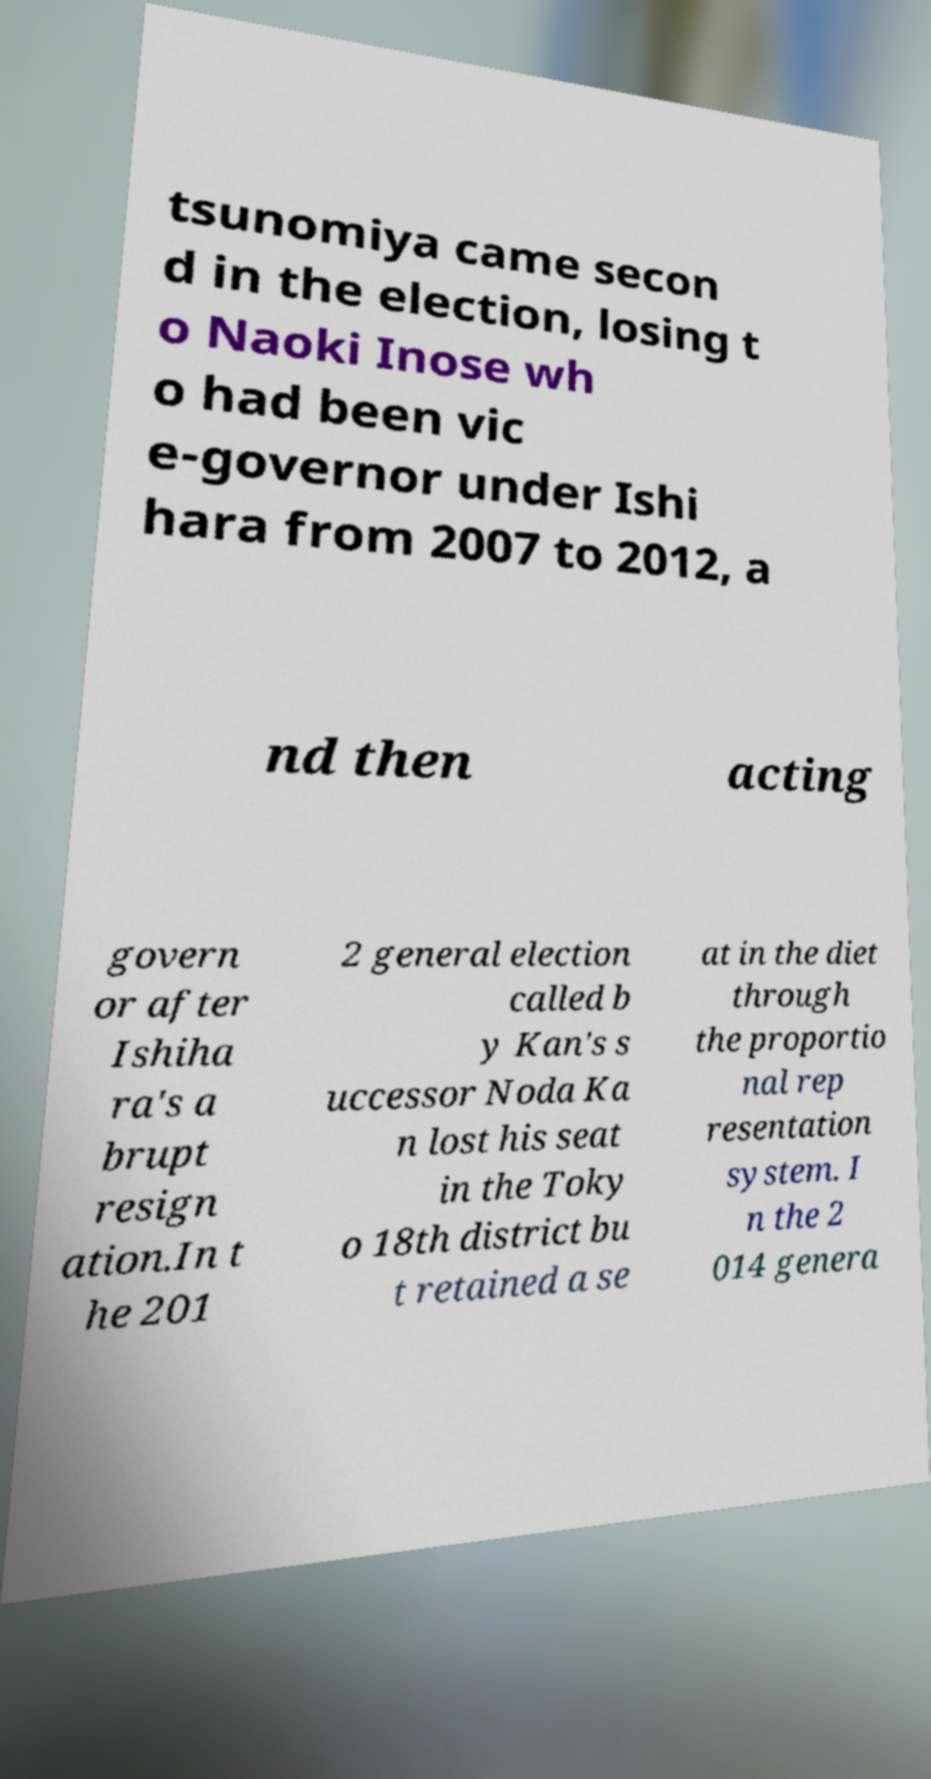Can you read and provide the text displayed in the image?This photo seems to have some interesting text. Can you extract and type it out for me? tsunomiya came secon d in the election, losing t o Naoki Inose wh o had been vic e-governor under Ishi hara from 2007 to 2012, a nd then acting govern or after Ishiha ra's a brupt resign ation.In t he 201 2 general election called b y Kan's s uccessor Noda Ka n lost his seat in the Toky o 18th district bu t retained a se at in the diet through the proportio nal rep resentation system. I n the 2 014 genera 